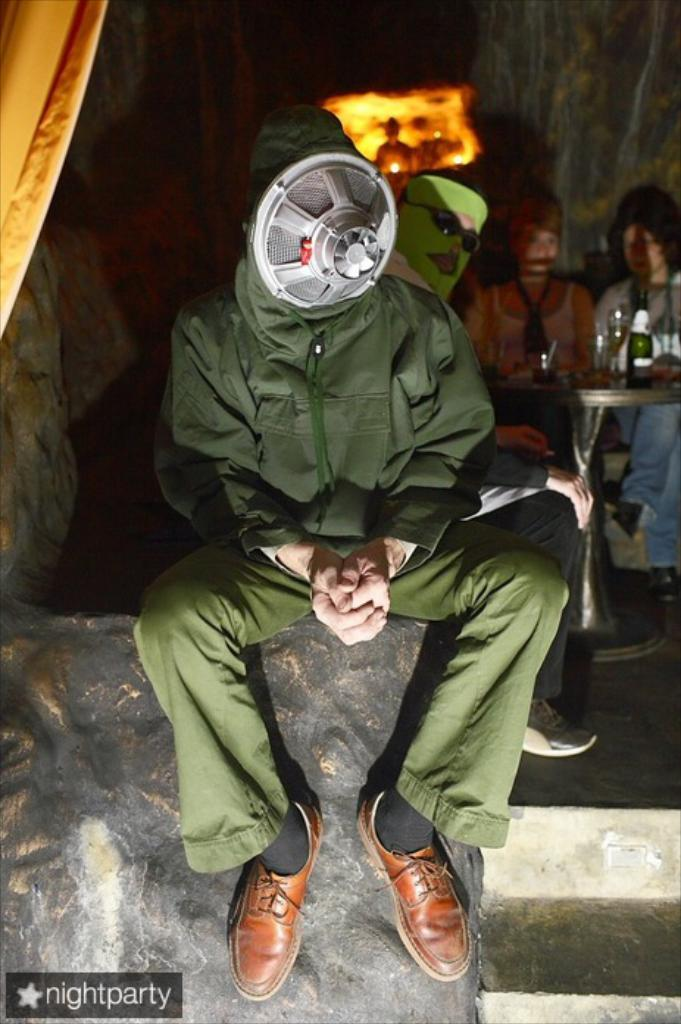What are the people in the image doing? The people in the image are sitting. What are the two men wearing on their faces? The two men are wearing masks. Can you describe the architectural feature in the image? There is a staircase in the image. What is the source of light in the image? There is a light in the image. What is on the table in the image? The table contains glasses and a bottle. What color is the balloon floating above the table in the image? There is no balloon present in the image. How does the growth of the plants in the image contribute to the atmosphere? There are no plants present in the image, so their growth cannot contribute to the atmosphere. 